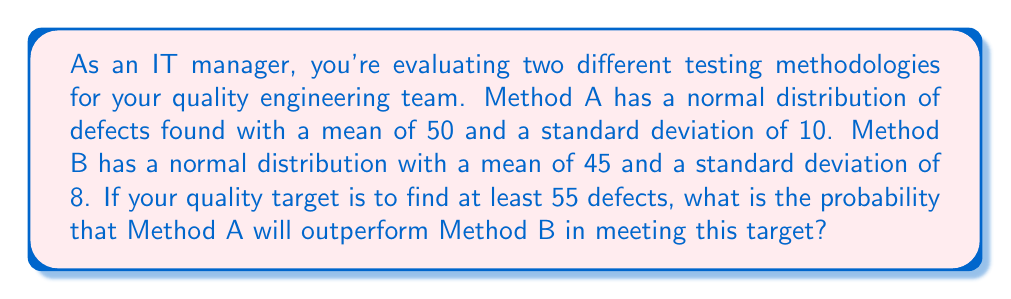Can you solve this math problem? To solve this problem, we need to follow these steps:

1. Calculate the z-score for 55 defects for both methods:

For Method A:
$$ z_A = \frac{55 - 50}{10} = 0.5 $$

For Method B:
$$ z_B = \frac{55 - 45}{8} = 1.25 $$

2. Find the probability of each method finding at least 55 defects:

For Method A:
$$ P(A \geq 55) = 1 - \Phi(0.5) = 0.3085 $$

For Method B:
$$ P(B \geq 55) = 1 - \Phi(1.25) = 0.1056 $$

Where $\Phi(z)$ is the cumulative distribution function of the standard normal distribution.

3. Calculate the probability that Method A outperforms Method B:

$$ P(A \text{ outperforms } B) = P(A \geq 55) - P(A \geq 55 \text{ and } B \geq 55) $$

$$ = P(A \geq 55) - [P(A \geq 55) \times P(B \geq 55)] $$
$$ = 0.3085 - (0.3085 \times 0.1056) $$
$$ = 0.3085 - 0.0326 $$
$$ = 0.2759 $$

Therefore, the probability that Method A will outperform Method B in meeting the target of finding at least 55 defects is approximately 0.2759 or 27.59%.
Answer: 0.2759 